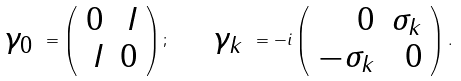<formula> <loc_0><loc_0><loc_500><loc_500>\begin{array} { c } \gamma _ { 0 } \end{array} = \left ( \begin{array} { r r } 0 & I \\ I & 0 \end{array} \right ) ; \quad \begin{array} { c } \gamma _ { k } \end{array} = - i \left ( \begin{array} { r r } 0 & \sigma _ { k } \\ - \sigma _ { k } & 0 \end{array} \right ) .</formula> 